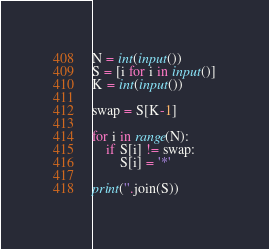<code> <loc_0><loc_0><loc_500><loc_500><_Python_>N = int(input())
S = [i for i in input()]
K = int(input())

swap = S[K-1]

for i in range(N):
    if S[i] != swap:
        S[i] = '*'

print(''.join(S))
</code> 